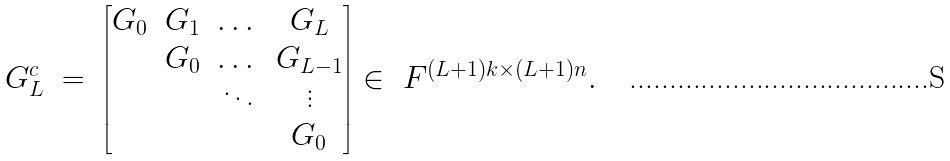<formula> <loc_0><loc_0><loc_500><loc_500>\begin{array} { r c l } G ^ { c } _ { L } & = & \begin{bmatrix} G _ { 0 } & G _ { 1 } & \dots & G _ { L } \\ & G _ { 0 } & \dots & G _ { L - 1 } \\ & & \ddots & \vdots \\ & & & G _ { 0 } \end{bmatrix} \in \ F ^ { ( L + 1 ) k \times ( L + 1 ) n } . \end{array}</formula> 